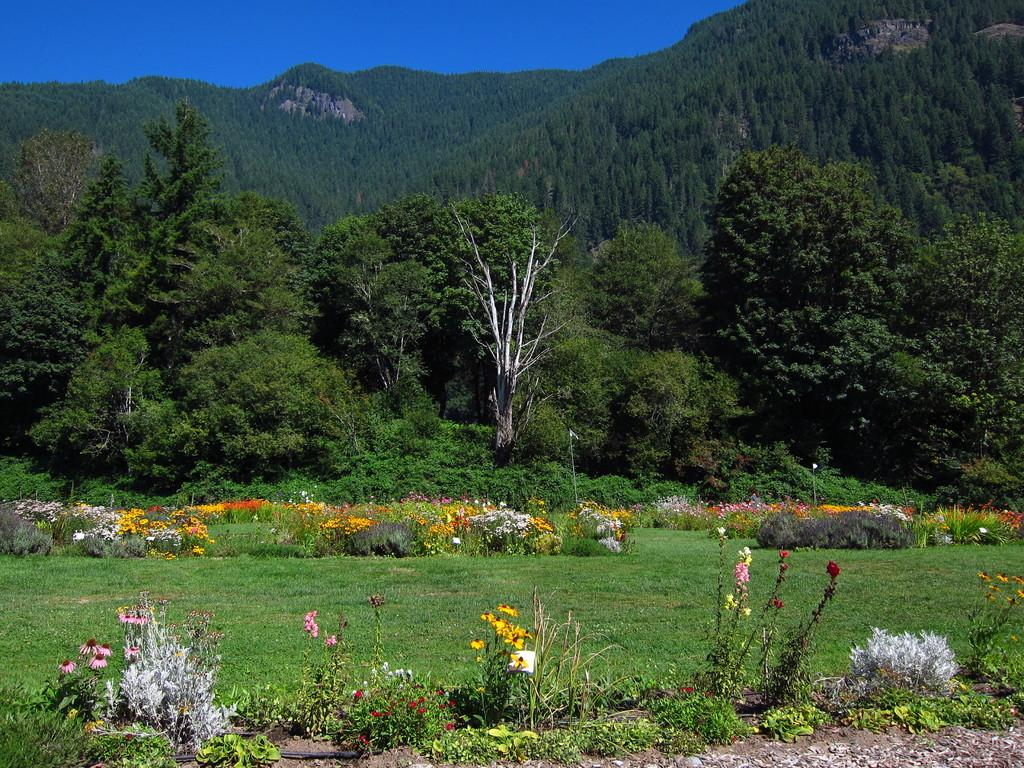What type of vegetation can be seen in the image? There are flower plants and trees in the image. What natural landmarks are visible in the image? There are mountains in the image. What is visible in the background of the image? The sky is visible in the image. How many oranges are hanging from the trees in the image? There are no oranges present in the image; it features flower plants, trees, mountains, and the sky. 